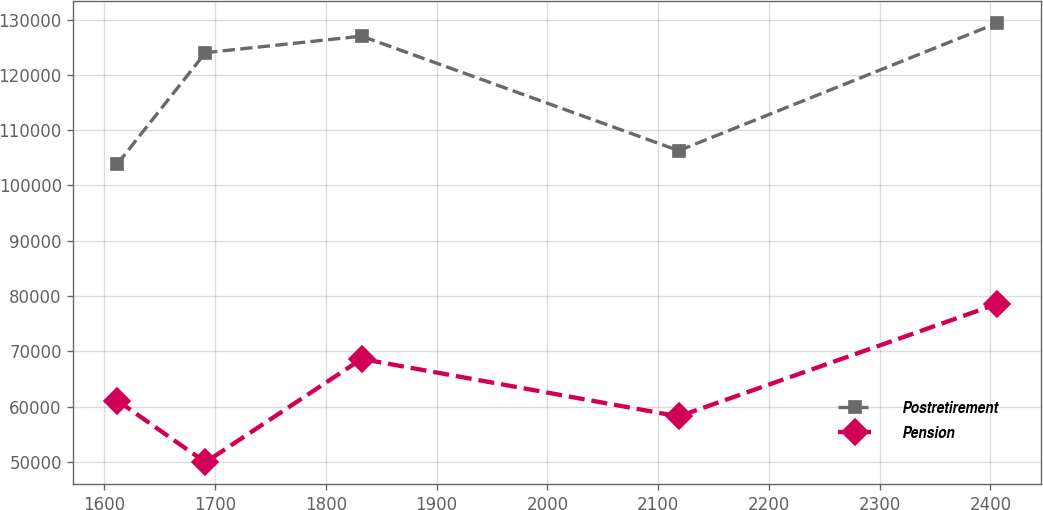<chart> <loc_0><loc_0><loc_500><loc_500><line_chart><ecel><fcel>Postretirement<fcel>Pension<nl><fcel>1611.96<fcel>103918<fcel>61073.6<nl><fcel>1691.38<fcel>124022<fcel>49915.9<nl><fcel>1832.41<fcel>127012<fcel>68612.8<nl><fcel>2118.61<fcel>106295<fcel>58208.5<nl><fcel>2406.18<fcel>129388<fcel>78566.9<nl></chart> 